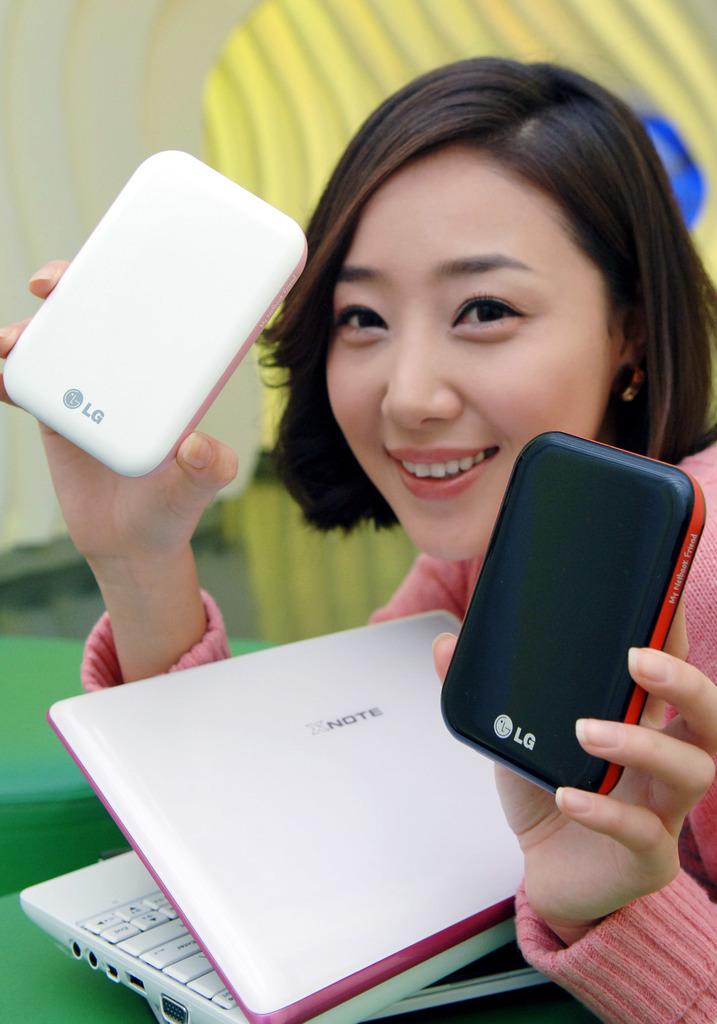What brand of phone is she holding?
Keep it short and to the point. Lg. 